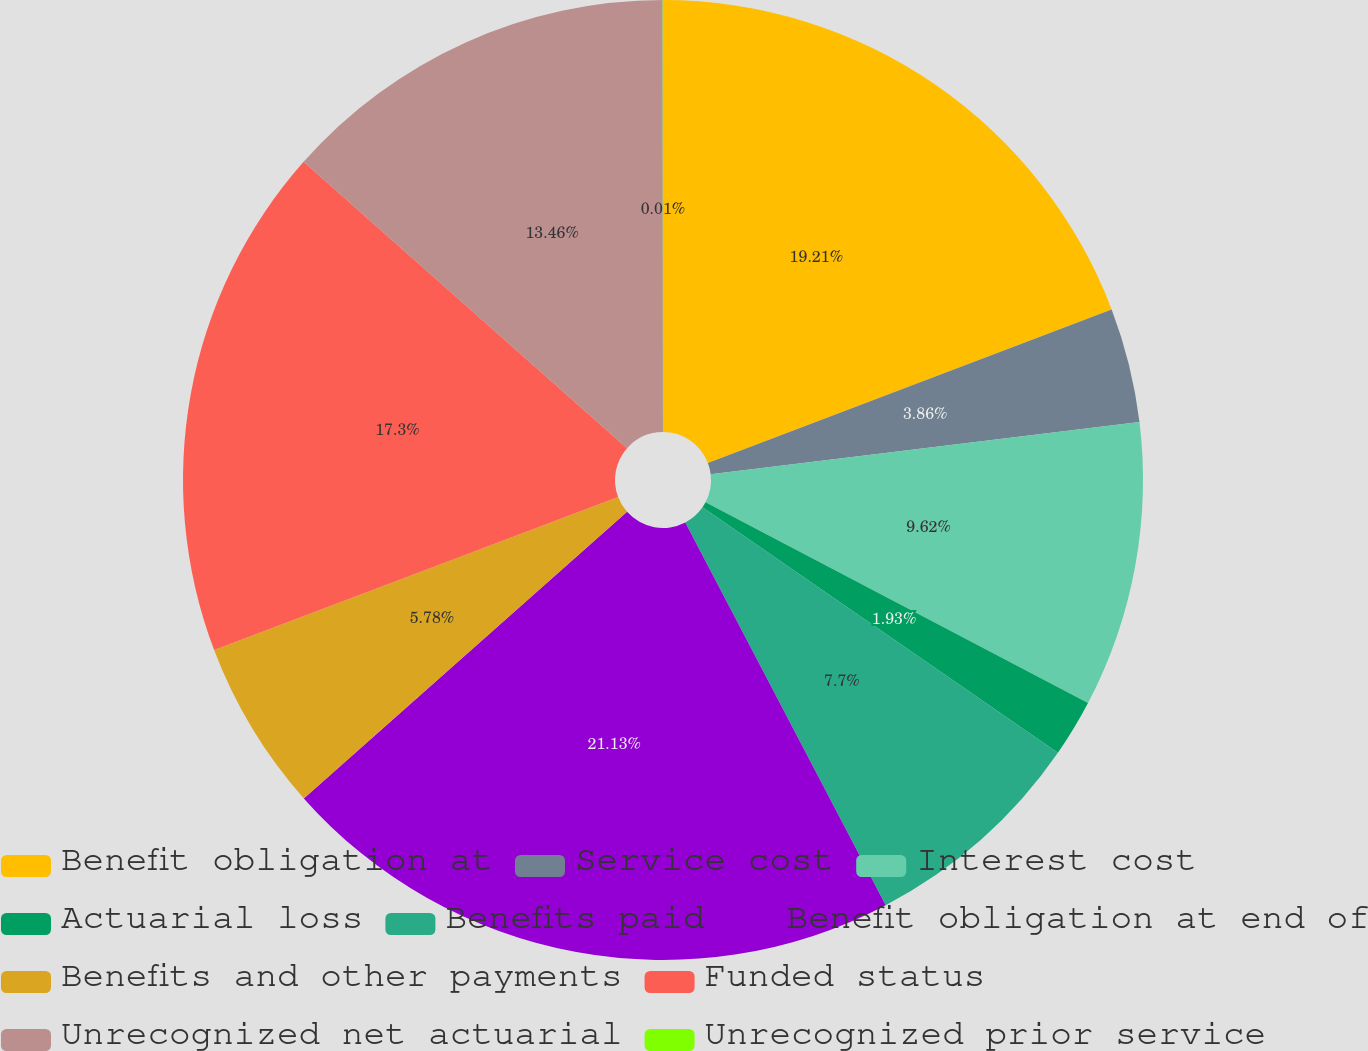Convert chart to OTSL. <chart><loc_0><loc_0><loc_500><loc_500><pie_chart><fcel>Benefit obligation at<fcel>Service cost<fcel>Interest cost<fcel>Actuarial loss<fcel>Benefits paid<fcel>Benefit obligation at end of<fcel>Benefits and other payments<fcel>Funded status<fcel>Unrecognized net actuarial<fcel>Unrecognized prior service<nl><fcel>19.22%<fcel>3.86%<fcel>9.62%<fcel>1.93%<fcel>7.7%<fcel>21.14%<fcel>5.78%<fcel>17.3%<fcel>13.46%<fcel>0.01%<nl></chart> 